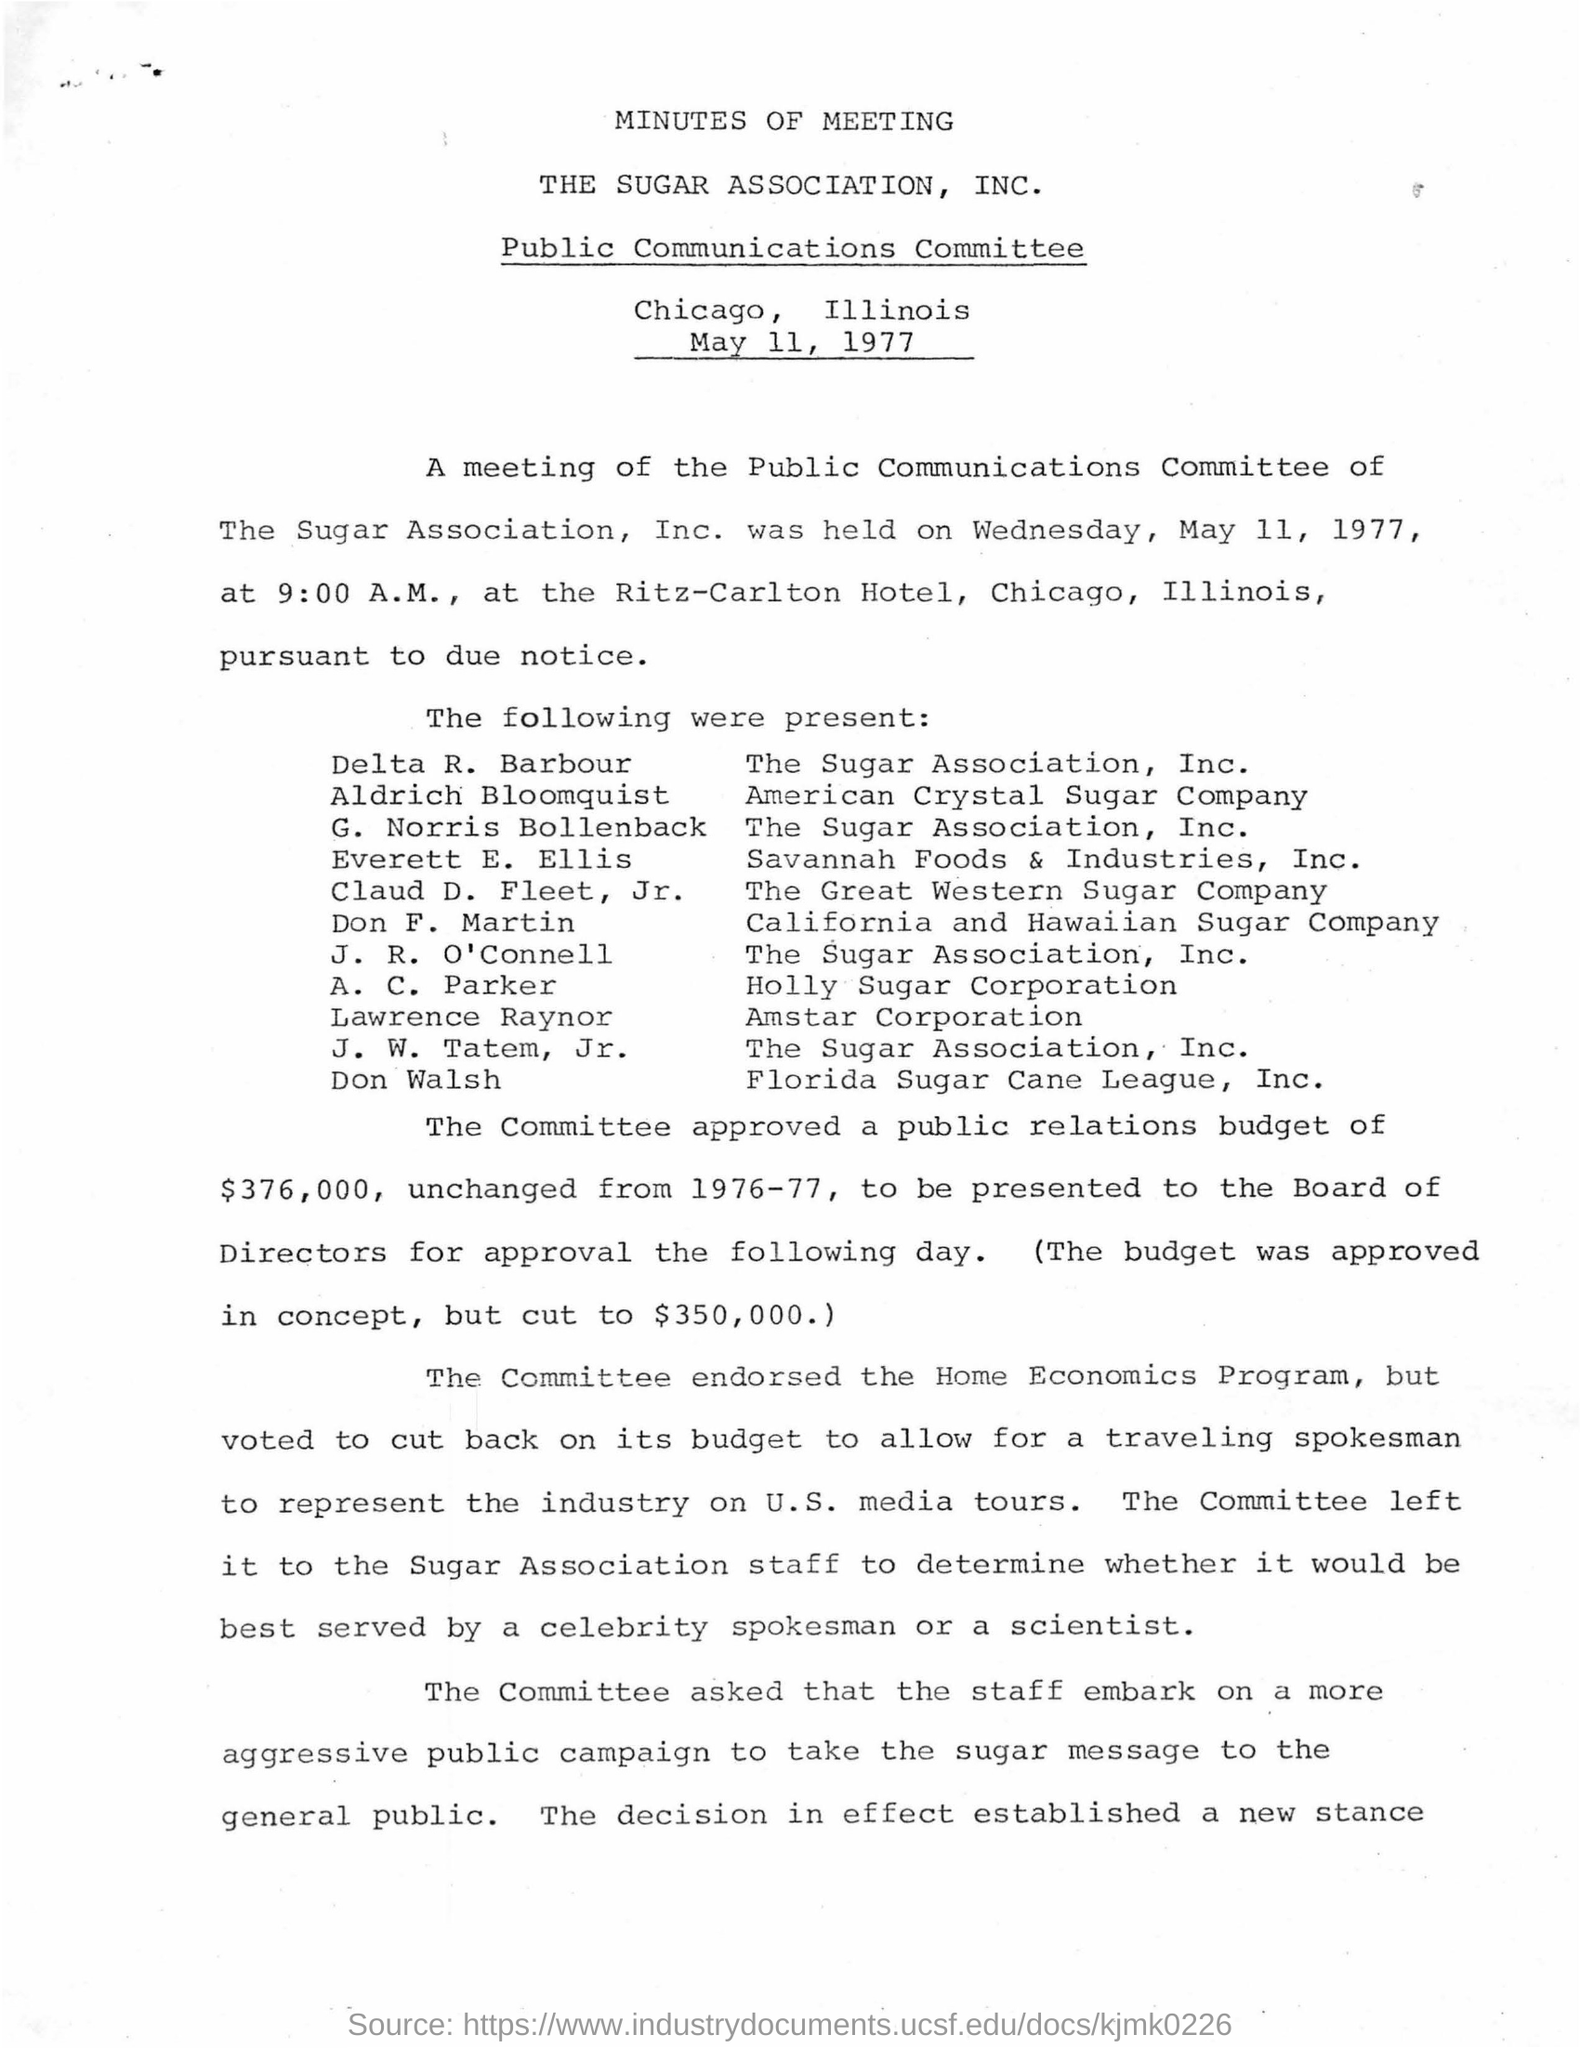When was the meeting of the Public Communications Committee of The Sugar Association, Inc. held?
Provide a succinct answer. On wednesday, may 11, 1977, at 9:00 a.m. Delta r.barbour belongs to which company ?
Provide a short and direct response. The sugar association ,inc. Which person belongs to florida sugar cane league,inc ?
Your response must be concise. Don walsh. A.C.Parker belongs to which sugar company ?
Offer a very short reply. Holly sugar corporation. What is the amount of  public relations budget approved by the committee ?
Your answer should be compact. $ 376,000. What is the program endorsed by the committee ?
Your answer should be very brief. Home economics program. 